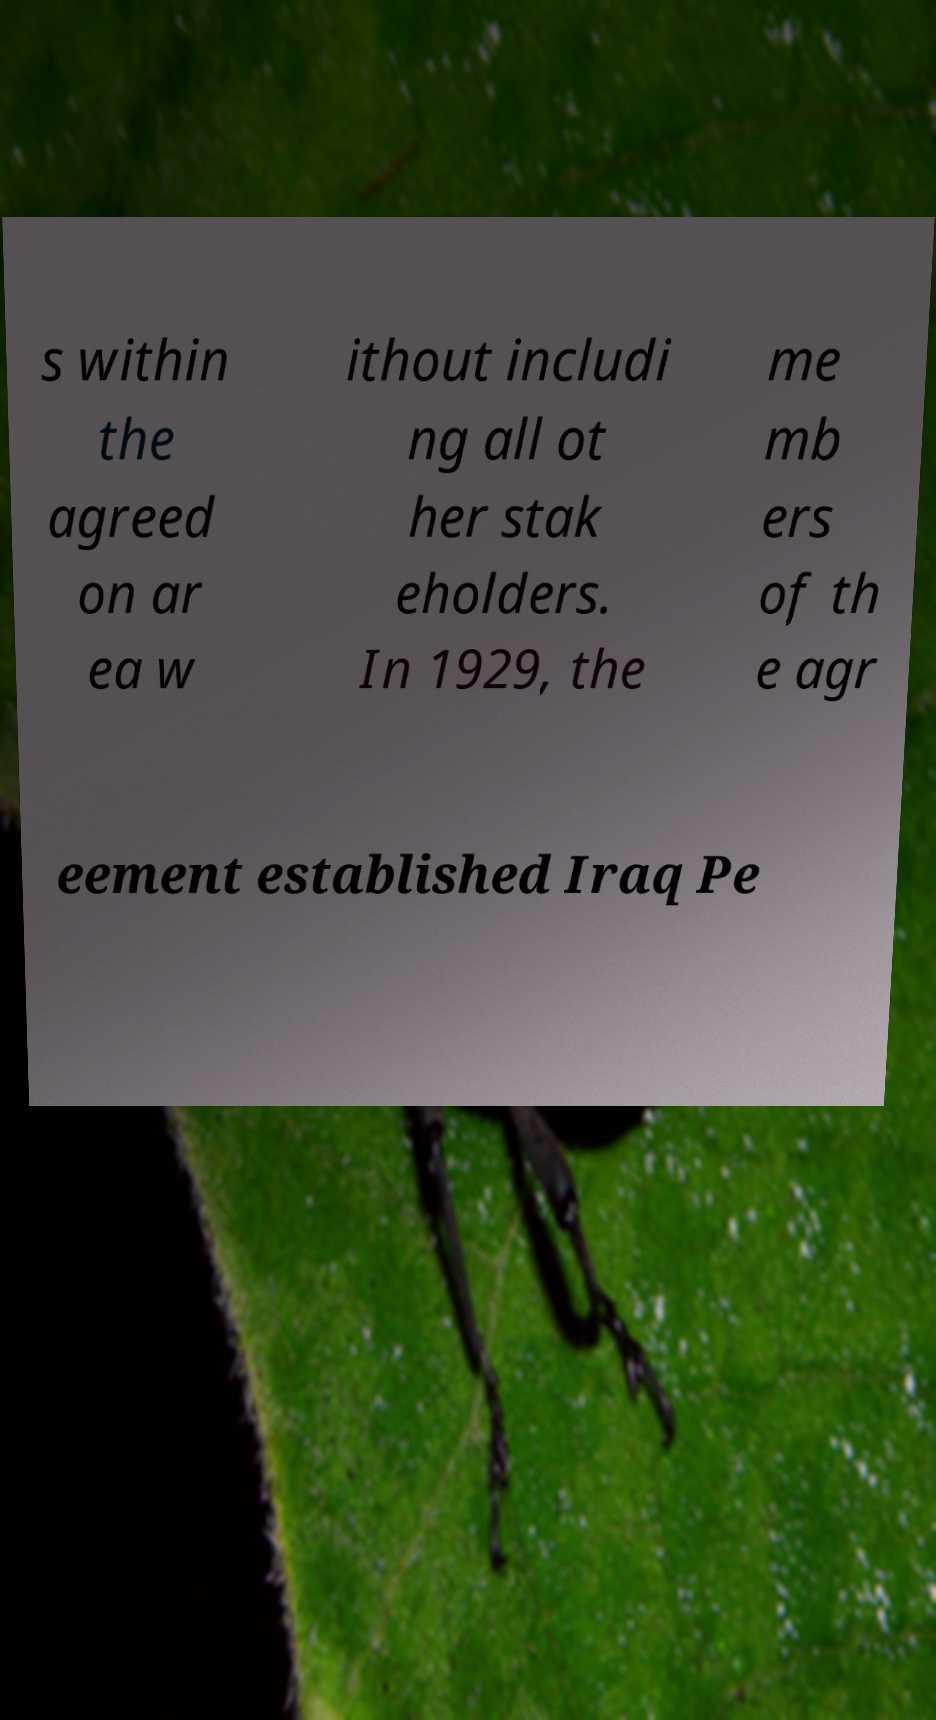Could you assist in decoding the text presented in this image and type it out clearly? s within the agreed on ar ea w ithout includi ng all ot her stak eholders. In 1929, the me mb ers of th e agr eement established Iraq Pe 